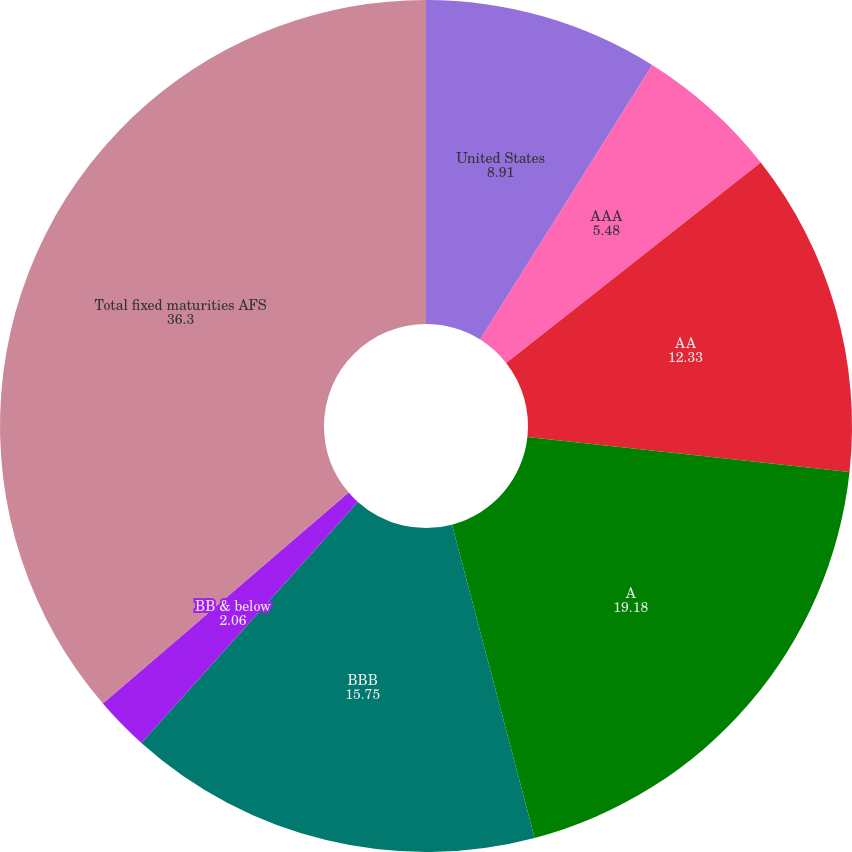Convert chart to OTSL. <chart><loc_0><loc_0><loc_500><loc_500><pie_chart><fcel>United States<fcel>AAA<fcel>AA<fcel>A<fcel>BBB<fcel>BB & below<fcel>Total fixed maturities AFS<nl><fcel>8.91%<fcel>5.48%<fcel>12.33%<fcel>19.18%<fcel>15.75%<fcel>2.06%<fcel>36.3%<nl></chart> 